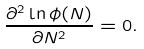Convert formula to latex. <formula><loc_0><loc_0><loc_500><loc_500>\frac { \partial ^ { 2 } \ln \phi ( N ) } { \partial N ^ { 2 } } = 0 .</formula> 